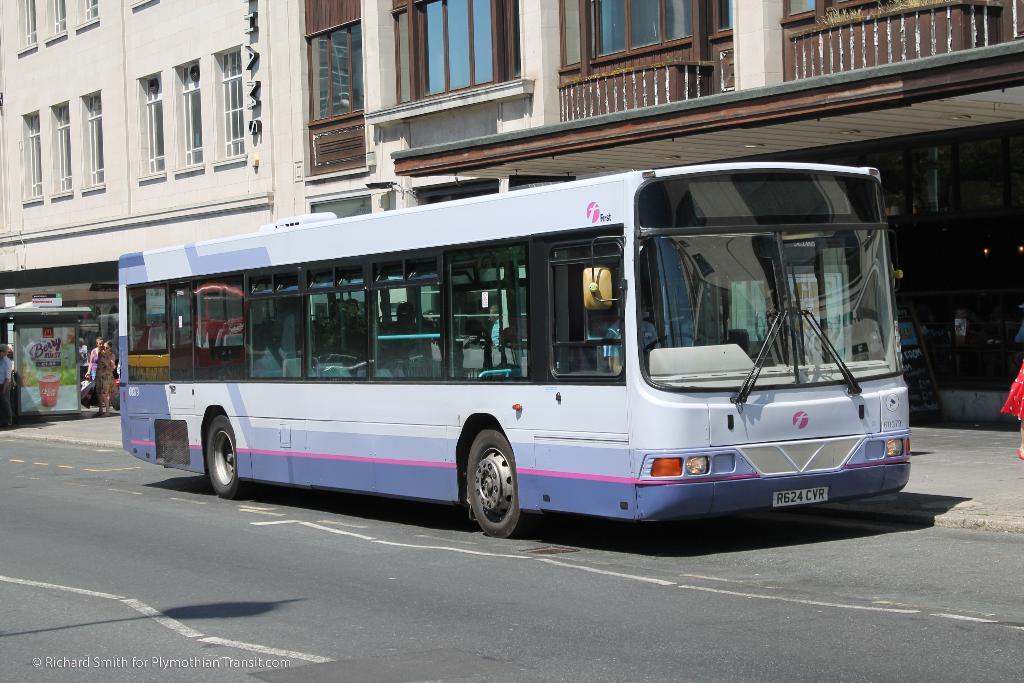How many people are in the image? There are people in the image, but the exact number is not specified. What are the people doing in the image? The people are in a vehicle, which suggests they might be traveling or commuting. What can be seen in the background of the image? There is a road, a store, and a building with windows visible in the image. What type of entrance is present in the building? There are glass doors in the building. What type of barrier is present in the image? There is fencing in the image. What color of glue is being used by the people in the image? There is no mention of glue or any color associated with it in the image. 